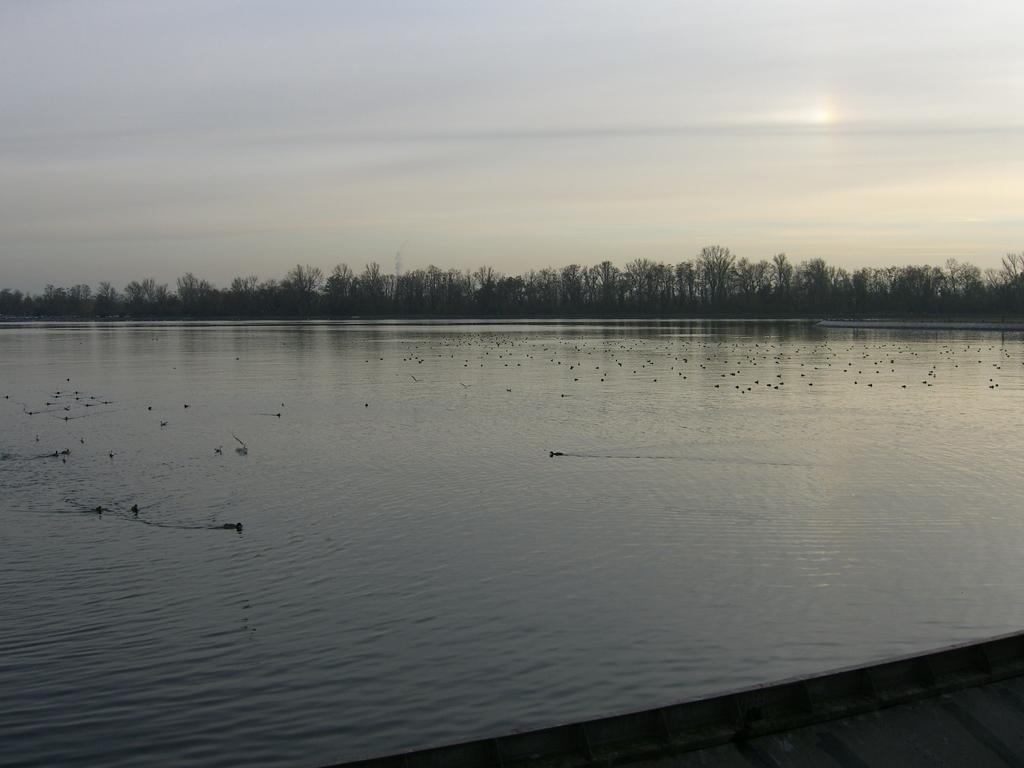Please provide a concise description of this image. In this picture I can see there is a river, there are few birds swimming in the water and in the backdrop there are trees and the sky is clear. 